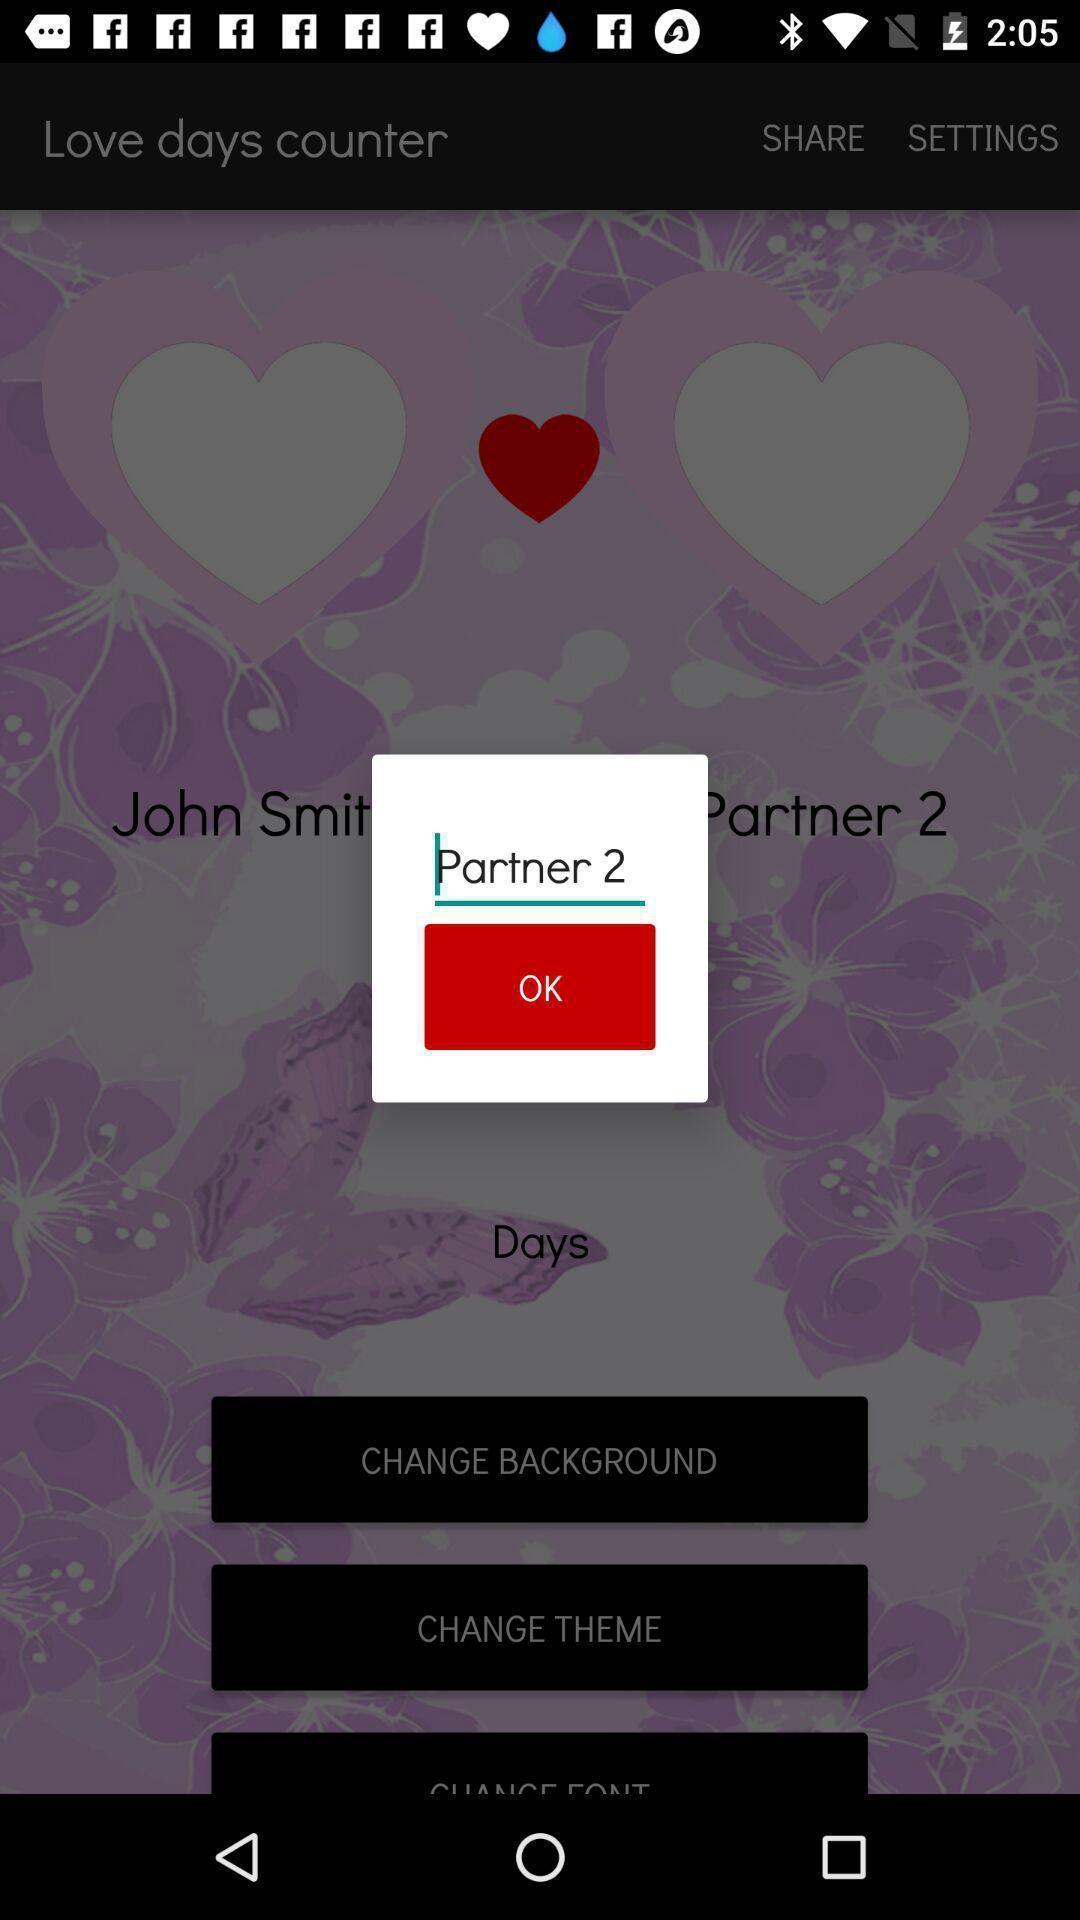Give me a narrative description of this picture. Pop-up asking second partner name in the app. 